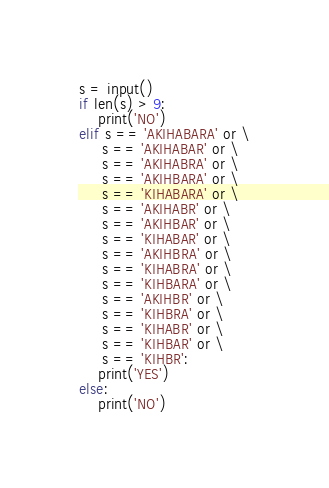<code> <loc_0><loc_0><loc_500><loc_500><_Python_>s = input()
if len(s) > 9:
    print('NO')
elif s == 'AKIHABARA' or \
     s == 'AKIHABAR' or \
     s == 'AKIHABRA' or \
     s == 'AKIHBARA' or \
     s == 'KIHABARA' or \
     s == 'AKIHABR' or \
     s == 'AKIHBAR' or \
     s == 'KIHABAR' or \
     s == 'AKIHBRA' or \
     s == 'KIHABRA' or \
     s == 'KIHBARA' or \
     s == 'AKIHBR' or \
     s == 'KIHBRA' or \
     s == 'KIHABR' or \
     s == 'KIHBAR' or \
     s == 'KIHBR':
    print('YES')
else:
    print('NO')

</code> 